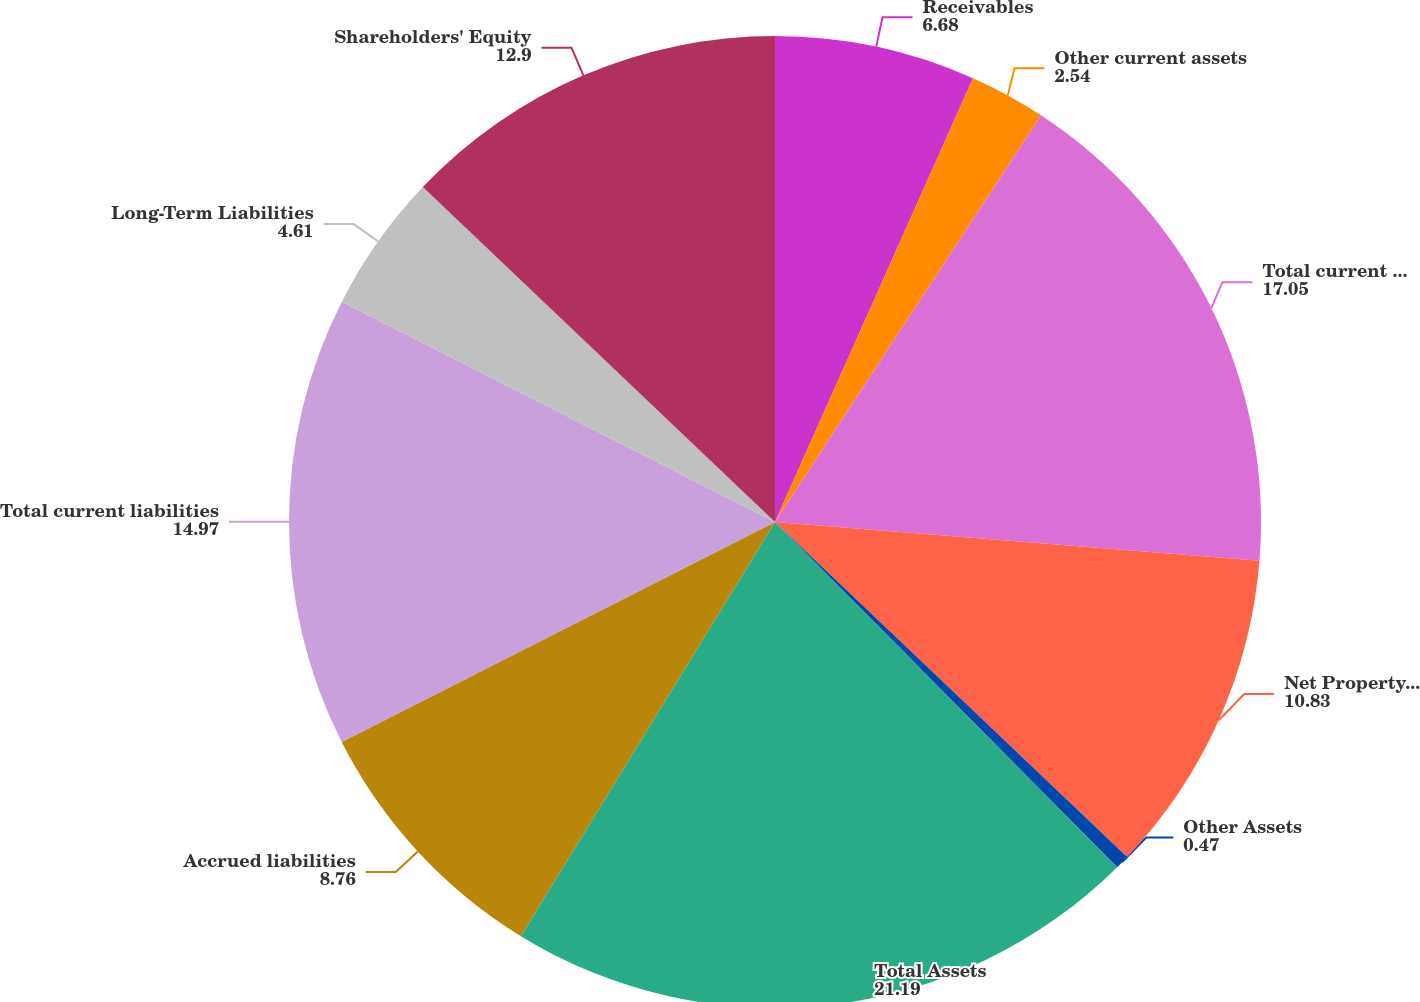Convert chart to OTSL. <chart><loc_0><loc_0><loc_500><loc_500><pie_chart><fcel>Receivables<fcel>Other current assets<fcel>Total current assets<fcel>Net Property and Equipment<fcel>Other Assets<fcel>Total Assets<fcel>Accrued liabilities<fcel>Total current liabilities<fcel>Long-Term Liabilities<fcel>Shareholders' Equity<nl><fcel>6.68%<fcel>2.54%<fcel>17.05%<fcel>10.83%<fcel>0.47%<fcel>21.19%<fcel>8.76%<fcel>14.97%<fcel>4.61%<fcel>12.9%<nl></chart> 